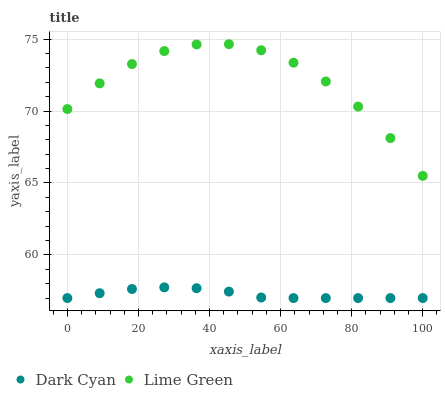Does Dark Cyan have the minimum area under the curve?
Answer yes or no. Yes. Does Lime Green have the maximum area under the curve?
Answer yes or no. Yes. Does Lime Green have the minimum area under the curve?
Answer yes or no. No. Is Dark Cyan the smoothest?
Answer yes or no. Yes. Is Lime Green the roughest?
Answer yes or no. Yes. Is Lime Green the smoothest?
Answer yes or no. No. Does Dark Cyan have the lowest value?
Answer yes or no. Yes. Does Lime Green have the lowest value?
Answer yes or no. No. Does Lime Green have the highest value?
Answer yes or no. Yes. Is Dark Cyan less than Lime Green?
Answer yes or no. Yes. Is Lime Green greater than Dark Cyan?
Answer yes or no. Yes. Does Dark Cyan intersect Lime Green?
Answer yes or no. No. 